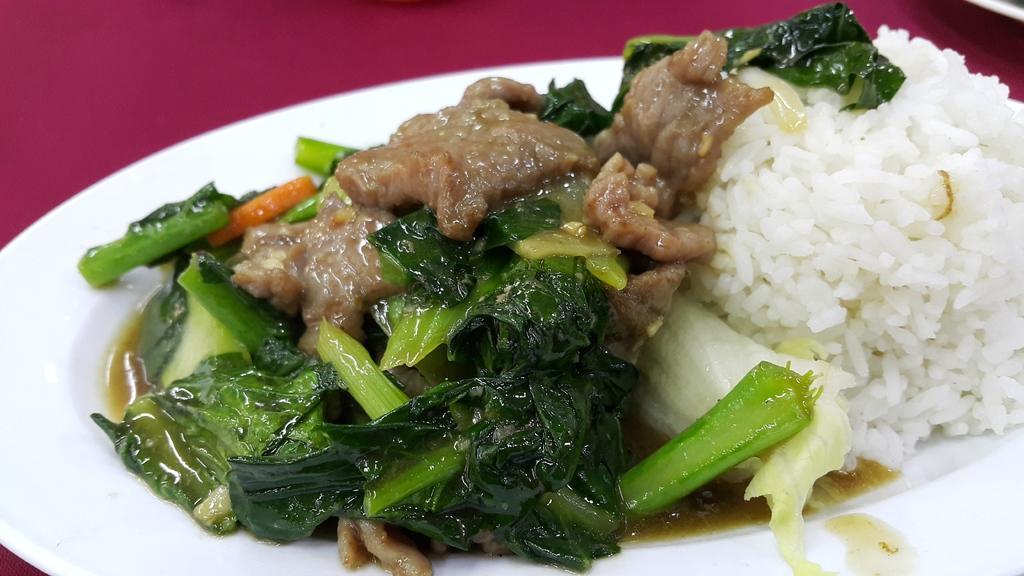In one or two sentences, can you explain what this image depicts? In this image there is a maroon color background. There is a plate. We can see the food on the plate. There is rice and green leaf vegetable. 